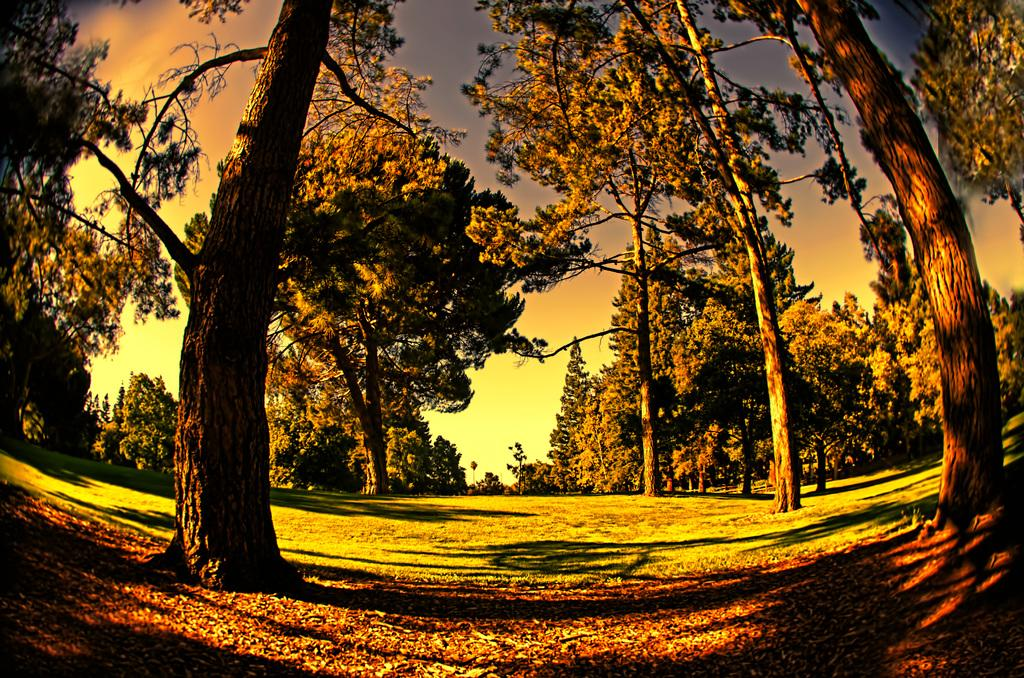What type of vegetation can be seen in the image? There are trees in the image. What part of the natural environment is visible in the image? The sky is visible in the image. What type of ground cover can be seen in the image? Dry leaves and grass are visible in the image. What colors are present in the lighting of the image? There is green, orange, and yellow color lighting in the image. Is there a discussion taking place between the trees in the image? No, there is no discussion taking place between the trees in the image, as trees do not have the ability to engage in discussions. Is it summer in the image? The provided facts do not give any information about the season, so it cannot be determined if it is summer in the image. 